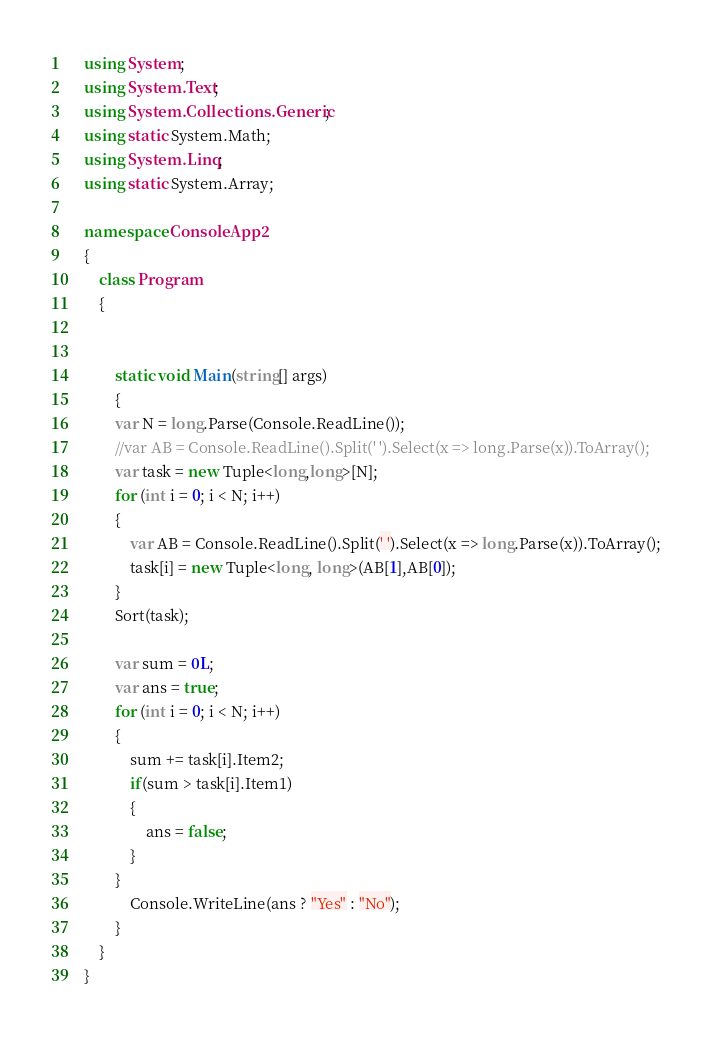Convert code to text. <code><loc_0><loc_0><loc_500><loc_500><_C#_>    using System;
    using System.Text;
    using System.Collections.Generic;
    using static System.Math;
    using System.Linq;
    using static System.Array;

    namespace ConsoleApp2
    {
        class Program
        {


            static void Main(string[] args)
            {
            var N = long.Parse(Console.ReadLine());
            //var AB = Console.ReadLine().Split(' ').Select(x => long.Parse(x)).ToArray();
            var task = new Tuple<long,long>[N];
            for (int i = 0; i < N; i++)
            {
                var AB = Console.ReadLine().Split(' ').Select(x => long.Parse(x)).ToArray();
                task[i] = new Tuple<long, long>(AB[1],AB[0]);
            }
            Sort(task);

            var sum = 0L;
            var ans = true;
            for (int i = 0; i < N; i++)
            {
                sum += task[i].Item2;
                if(sum > task[i].Item1)
                {
                    ans = false;
                }
            }
                Console.WriteLine(ans ? "Yes" : "No");
            }
        }
    }
</code> 